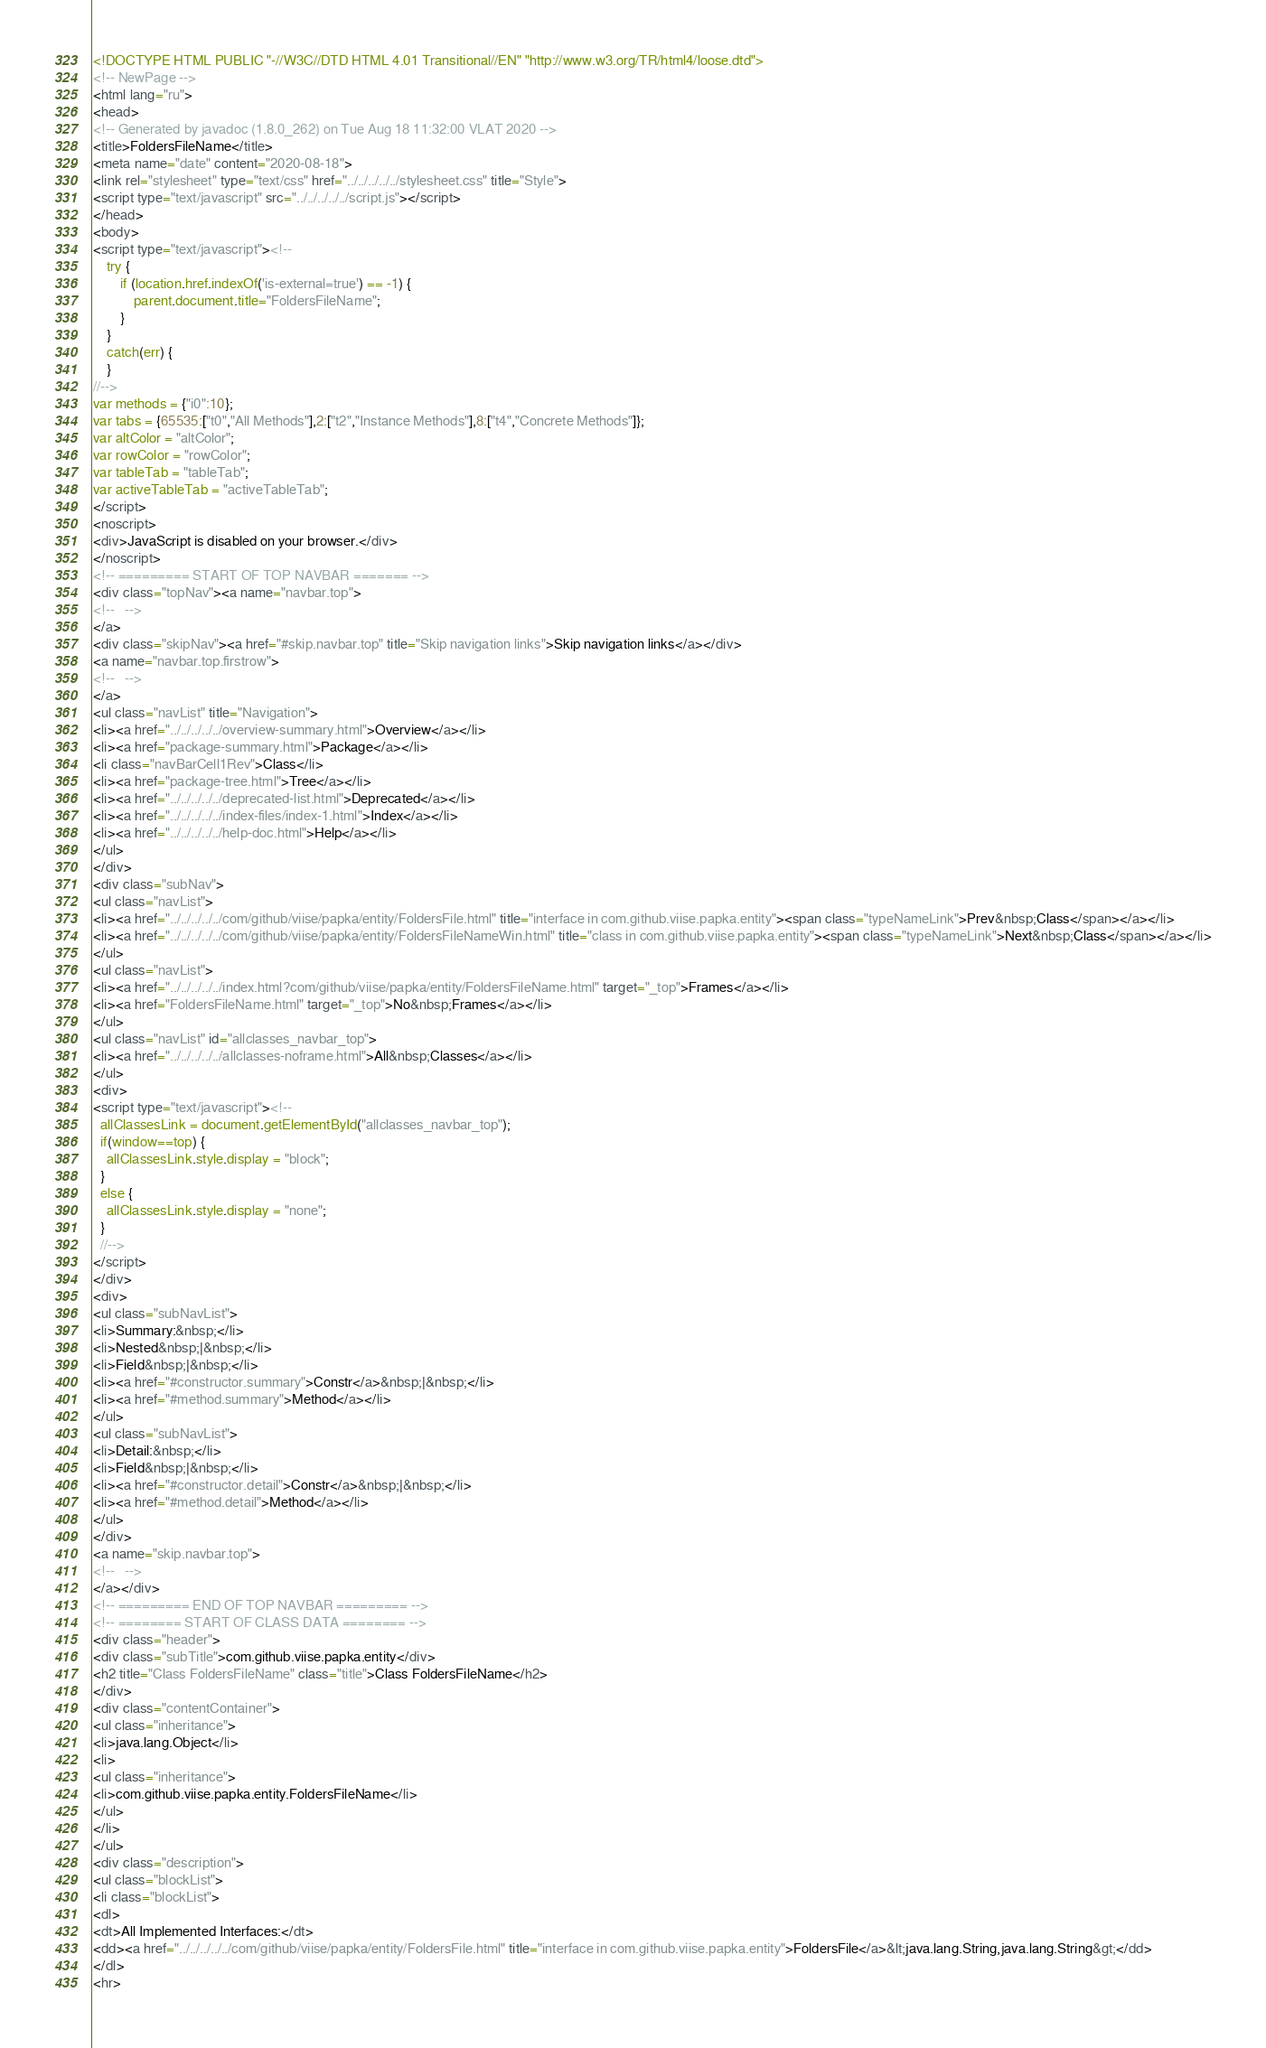<code> <loc_0><loc_0><loc_500><loc_500><_HTML_><!DOCTYPE HTML PUBLIC "-//W3C//DTD HTML 4.01 Transitional//EN" "http://www.w3.org/TR/html4/loose.dtd">
<!-- NewPage -->
<html lang="ru">
<head>
<!-- Generated by javadoc (1.8.0_262) on Tue Aug 18 11:32:00 VLAT 2020 -->
<title>FoldersFileName</title>
<meta name="date" content="2020-08-18">
<link rel="stylesheet" type="text/css" href="../../../../../stylesheet.css" title="Style">
<script type="text/javascript" src="../../../../../script.js"></script>
</head>
<body>
<script type="text/javascript"><!--
    try {
        if (location.href.indexOf('is-external=true') == -1) {
            parent.document.title="FoldersFileName";
        }
    }
    catch(err) {
    }
//-->
var methods = {"i0":10};
var tabs = {65535:["t0","All Methods"],2:["t2","Instance Methods"],8:["t4","Concrete Methods"]};
var altColor = "altColor";
var rowColor = "rowColor";
var tableTab = "tableTab";
var activeTableTab = "activeTableTab";
</script>
<noscript>
<div>JavaScript is disabled on your browser.</div>
</noscript>
<!-- ========= START OF TOP NAVBAR ======= -->
<div class="topNav"><a name="navbar.top">
<!--   -->
</a>
<div class="skipNav"><a href="#skip.navbar.top" title="Skip navigation links">Skip navigation links</a></div>
<a name="navbar.top.firstrow">
<!--   -->
</a>
<ul class="navList" title="Navigation">
<li><a href="../../../../../overview-summary.html">Overview</a></li>
<li><a href="package-summary.html">Package</a></li>
<li class="navBarCell1Rev">Class</li>
<li><a href="package-tree.html">Tree</a></li>
<li><a href="../../../../../deprecated-list.html">Deprecated</a></li>
<li><a href="../../../../../index-files/index-1.html">Index</a></li>
<li><a href="../../../../../help-doc.html">Help</a></li>
</ul>
</div>
<div class="subNav">
<ul class="navList">
<li><a href="../../../../../com/github/viise/papka/entity/FoldersFile.html" title="interface in com.github.viise.papka.entity"><span class="typeNameLink">Prev&nbsp;Class</span></a></li>
<li><a href="../../../../../com/github/viise/papka/entity/FoldersFileNameWin.html" title="class in com.github.viise.papka.entity"><span class="typeNameLink">Next&nbsp;Class</span></a></li>
</ul>
<ul class="navList">
<li><a href="../../../../../index.html?com/github/viise/papka/entity/FoldersFileName.html" target="_top">Frames</a></li>
<li><a href="FoldersFileName.html" target="_top">No&nbsp;Frames</a></li>
</ul>
<ul class="navList" id="allclasses_navbar_top">
<li><a href="../../../../../allclasses-noframe.html">All&nbsp;Classes</a></li>
</ul>
<div>
<script type="text/javascript"><!--
  allClassesLink = document.getElementById("allclasses_navbar_top");
  if(window==top) {
    allClassesLink.style.display = "block";
  }
  else {
    allClassesLink.style.display = "none";
  }
  //-->
</script>
</div>
<div>
<ul class="subNavList">
<li>Summary:&nbsp;</li>
<li>Nested&nbsp;|&nbsp;</li>
<li>Field&nbsp;|&nbsp;</li>
<li><a href="#constructor.summary">Constr</a>&nbsp;|&nbsp;</li>
<li><a href="#method.summary">Method</a></li>
</ul>
<ul class="subNavList">
<li>Detail:&nbsp;</li>
<li>Field&nbsp;|&nbsp;</li>
<li><a href="#constructor.detail">Constr</a>&nbsp;|&nbsp;</li>
<li><a href="#method.detail">Method</a></li>
</ul>
</div>
<a name="skip.navbar.top">
<!--   -->
</a></div>
<!-- ========= END OF TOP NAVBAR ========= -->
<!-- ======== START OF CLASS DATA ======== -->
<div class="header">
<div class="subTitle">com.github.viise.papka.entity</div>
<h2 title="Class FoldersFileName" class="title">Class FoldersFileName</h2>
</div>
<div class="contentContainer">
<ul class="inheritance">
<li>java.lang.Object</li>
<li>
<ul class="inheritance">
<li>com.github.viise.papka.entity.FoldersFileName</li>
</ul>
</li>
</ul>
<div class="description">
<ul class="blockList">
<li class="blockList">
<dl>
<dt>All Implemented Interfaces:</dt>
<dd><a href="../../../../../com/github/viise/papka/entity/FoldersFile.html" title="interface in com.github.viise.papka.entity">FoldersFile</a>&lt;java.lang.String,java.lang.String&gt;</dd>
</dl>
<hr></code> 